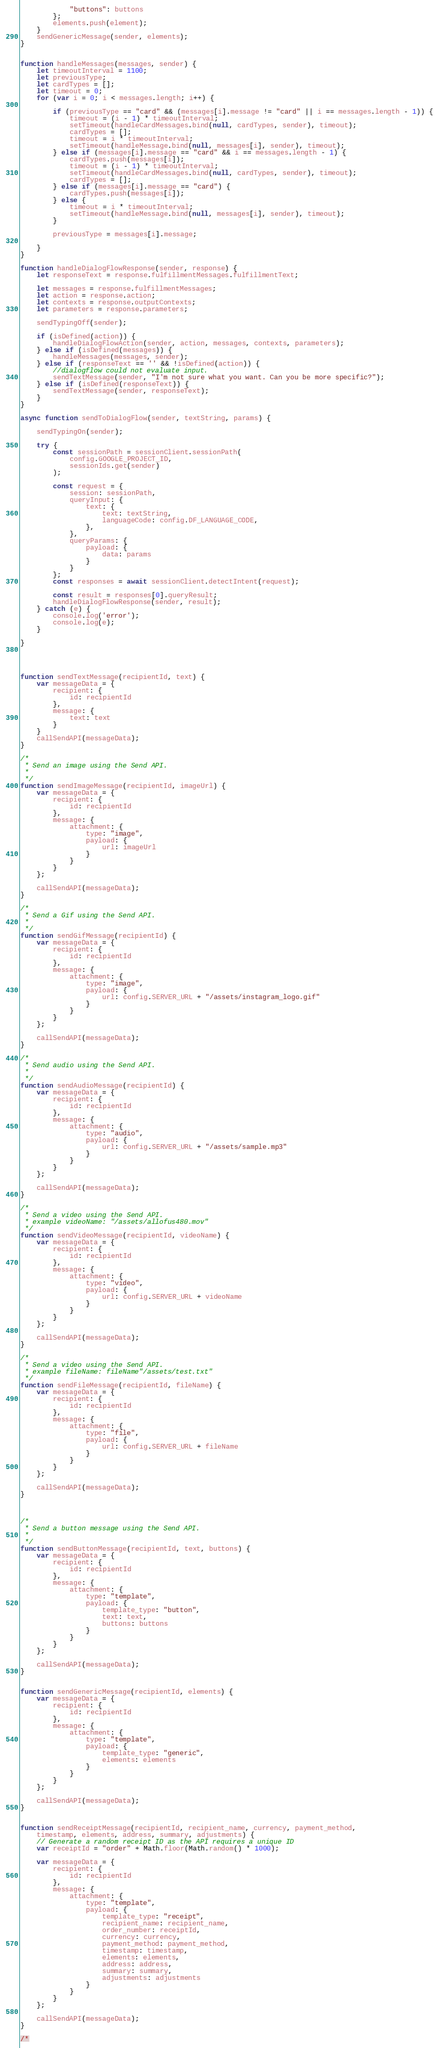<code> <loc_0><loc_0><loc_500><loc_500><_JavaScript_>            "buttons": buttons
        };
        elements.push(element);
    }
    sendGenericMessage(sender, elements);
}


function handleMessages(messages, sender) {
    let timeoutInterval = 1100;
    let previousType;
    let cardTypes = [];
    let timeout = 0;
    for (var i = 0; i < messages.length; i++) {

        if (previousType == "card" && (messages[i].message != "card" || i == messages.length - 1)) {
            timeout = (i - 1) * timeoutInterval;
            setTimeout(handleCardMessages.bind(null, cardTypes, sender), timeout);
            cardTypes = [];
            timeout = i * timeoutInterval;
            setTimeout(handleMessage.bind(null, messages[i], sender), timeout);
        } else if (messages[i].message == "card" && i == messages.length - 1) {
            cardTypes.push(messages[i]);
            timeout = (i - 1) * timeoutInterval;
            setTimeout(handleCardMessages.bind(null, cardTypes, sender), timeout);
            cardTypes = [];
        } else if (messages[i].message == "card") {
            cardTypes.push(messages[i]);
        } else {
            timeout = i * timeoutInterval;
            setTimeout(handleMessage.bind(null, messages[i], sender), timeout);
        }

        previousType = messages[i].message;

    }
}

function handleDialogFlowResponse(sender, response) {
    let responseText = response.fulfillmentMessages.fulfillmentText;

    let messages = response.fulfillmentMessages;
    let action = response.action;
    let contexts = response.outputContexts;
    let parameters = response.parameters;

    sendTypingOff(sender);

    if (isDefined(action)) {
        handleDialogFlowAction(sender, action, messages, contexts, parameters);
    } else if (isDefined(messages)) {
        handleMessages(messages, sender);
    } else if (responseText == '' && !isDefined(action)) {
        //dialogflow could not evaluate input.
        sendTextMessage(sender, "I'm not sure what you want. Can you be more specific?");
    } else if (isDefined(responseText)) {
        sendTextMessage(sender, responseText);
    }
}

async function sendToDialogFlow(sender, textString, params) {

    sendTypingOn(sender);

    try {
        const sessionPath = sessionClient.sessionPath(
            config.GOOGLE_PROJECT_ID,
            sessionIds.get(sender)
        );

        const request = {
            session: sessionPath,
            queryInput: {
                text: {
                    text: textString,
                    languageCode: config.DF_LANGUAGE_CODE,
                },
            },
            queryParams: {
                payload: {
                    data: params
                }
            }
        };
        const responses = await sessionClient.detectIntent(request);

        const result = responses[0].queryResult;
        handleDialogFlowResponse(sender, result);
    } catch (e) {
        console.log('error');
        console.log(e);
    }

}




function sendTextMessage(recipientId, text) {
    var messageData = {
        recipient: {
            id: recipientId
        },
        message: {
            text: text
        }
    }
    callSendAPI(messageData);
}

/*
 * Send an image using the Send API.
 *
 */
function sendImageMessage(recipientId, imageUrl) {
    var messageData = {
        recipient: {
            id: recipientId
        },
        message: {
            attachment: {
                type: "image",
                payload: {
                    url: imageUrl
                }
            }
        }
    };

    callSendAPI(messageData);
}

/*
 * Send a Gif using the Send API.
 *
 */
function sendGifMessage(recipientId) {
    var messageData = {
        recipient: {
            id: recipientId
        },
        message: {
            attachment: {
                type: "image",
                payload: {
                    url: config.SERVER_URL + "/assets/instagram_logo.gif"
                }
            }
        }
    };

    callSendAPI(messageData);
}

/*
 * Send audio using the Send API.
 *
 */
function sendAudioMessage(recipientId) {
    var messageData = {
        recipient: {
            id: recipientId
        },
        message: {
            attachment: {
                type: "audio",
                payload: {
                    url: config.SERVER_URL + "/assets/sample.mp3"
                }
            }
        }
    };

    callSendAPI(messageData);
}

/*
 * Send a video using the Send API.
 * example videoName: "/assets/allofus480.mov"
 */
function sendVideoMessage(recipientId, videoName) {
    var messageData = {
        recipient: {
            id: recipientId
        },
        message: {
            attachment: {
                type: "video",
                payload: {
                    url: config.SERVER_URL + videoName
                }
            }
        }
    };

    callSendAPI(messageData);
}

/*
 * Send a video using the Send API.
 * example fileName: fileName"/assets/test.txt"
 */
function sendFileMessage(recipientId, fileName) {
    var messageData = {
        recipient: {
            id: recipientId
        },
        message: {
            attachment: {
                type: "file",
                payload: {
                    url: config.SERVER_URL + fileName
                }
            }
        }
    };

    callSendAPI(messageData);
}



/*
 * Send a button message using the Send API.
 *
 */
function sendButtonMessage(recipientId, text, buttons) {
    var messageData = {
        recipient: {
            id: recipientId
        },
        message: {
            attachment: {
                type: "template",
                payload: {
                    template_type: "button",
                    text: text,
                    buttons: buttons
                }
            }
        }
    };

    callSendAPI(messageData);
}


function sendGenericMessage(recipientId, elements) {
    var messageData = {
        recipient: {
            id: recipientId
        },
        message: {
            attachment: {
                type: "template",
                payload: {
                    template_type: "generic",
                    elements: elements
                }
            }
        }
    };

    callSendAPI(messageData);
}


function sendReceiptMessage(recipientId, recipient_name, currency, payment_method,
    timestamp, elements, address, summary, adjustments) {
    // Generate a random receipt ID as the API requires a unique ID
    var receiptId = "order" + Math.floor(Math.random() * 1000);

    var messageData = {
        recipient: {
            id: recipientId
        },
        message: {
            attachment: {
                type: "template",
                payload: {
                    template_type: "receipt",
                    recipient_name: recipient_name,
                    order_number: receiptId,
                    currency: currency,
                    payment_method: payment_method,
                    timestamp: timestamp,
                    elements: elements,
                    address: address,
                    summary: summary,
                    adjustments: adjustments
                }
            }
        }
    };

    callSendAPI(messageData);
}

/*</code> 